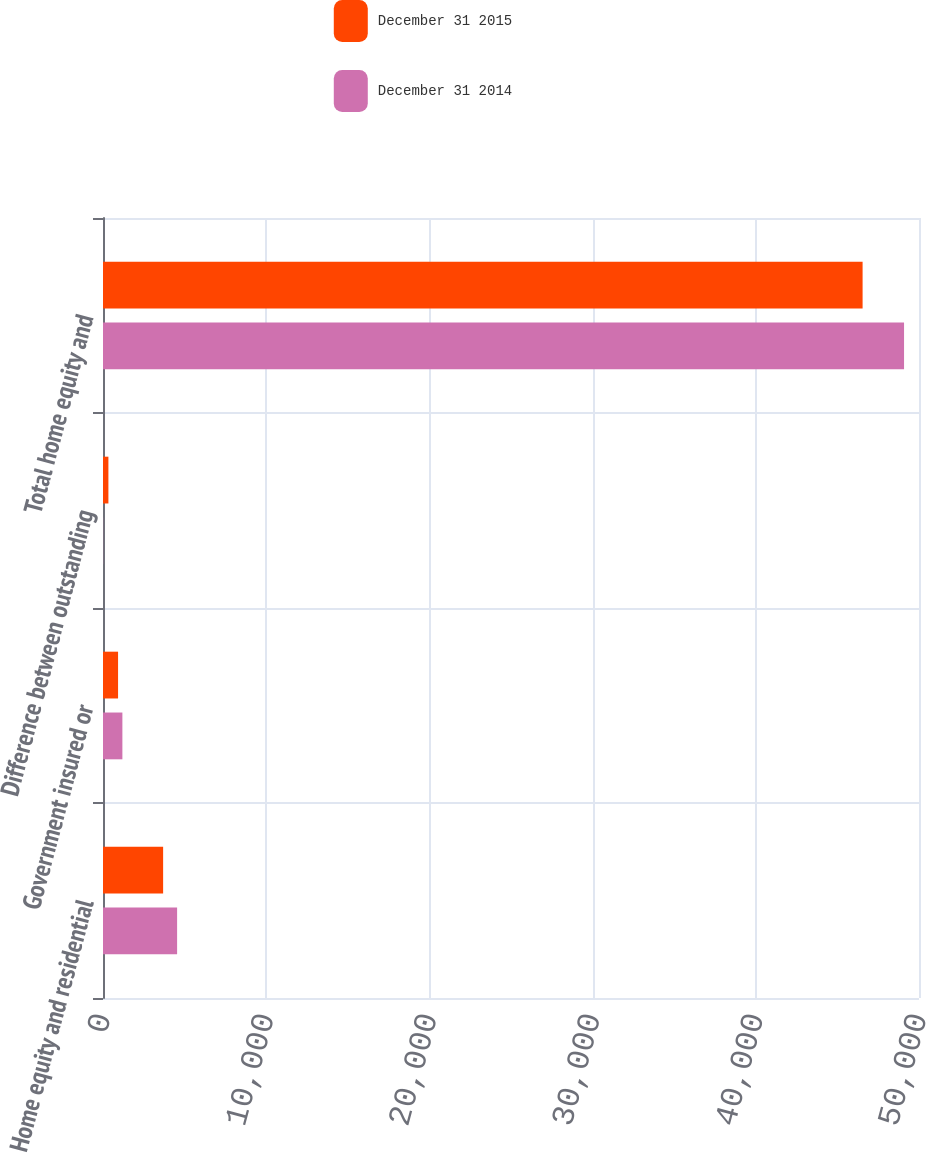Convert chart to OTSL. <chart><loc_0><loc_0><loc_500><loc_500><stacked_bar_chart><ecel><fcel>Home equity and residential<fcel>Government insured or<fcel>Difference between outstanding<fcel>Total home equity and<nl><fcel>December 31 2015<fcel>3684<fcel>923<fcel>331<fcel>46544<nl><fcel>December 31 2014<fcel>4541<fcel>1188<fcel>7<fcel>49084<nl></chart> 